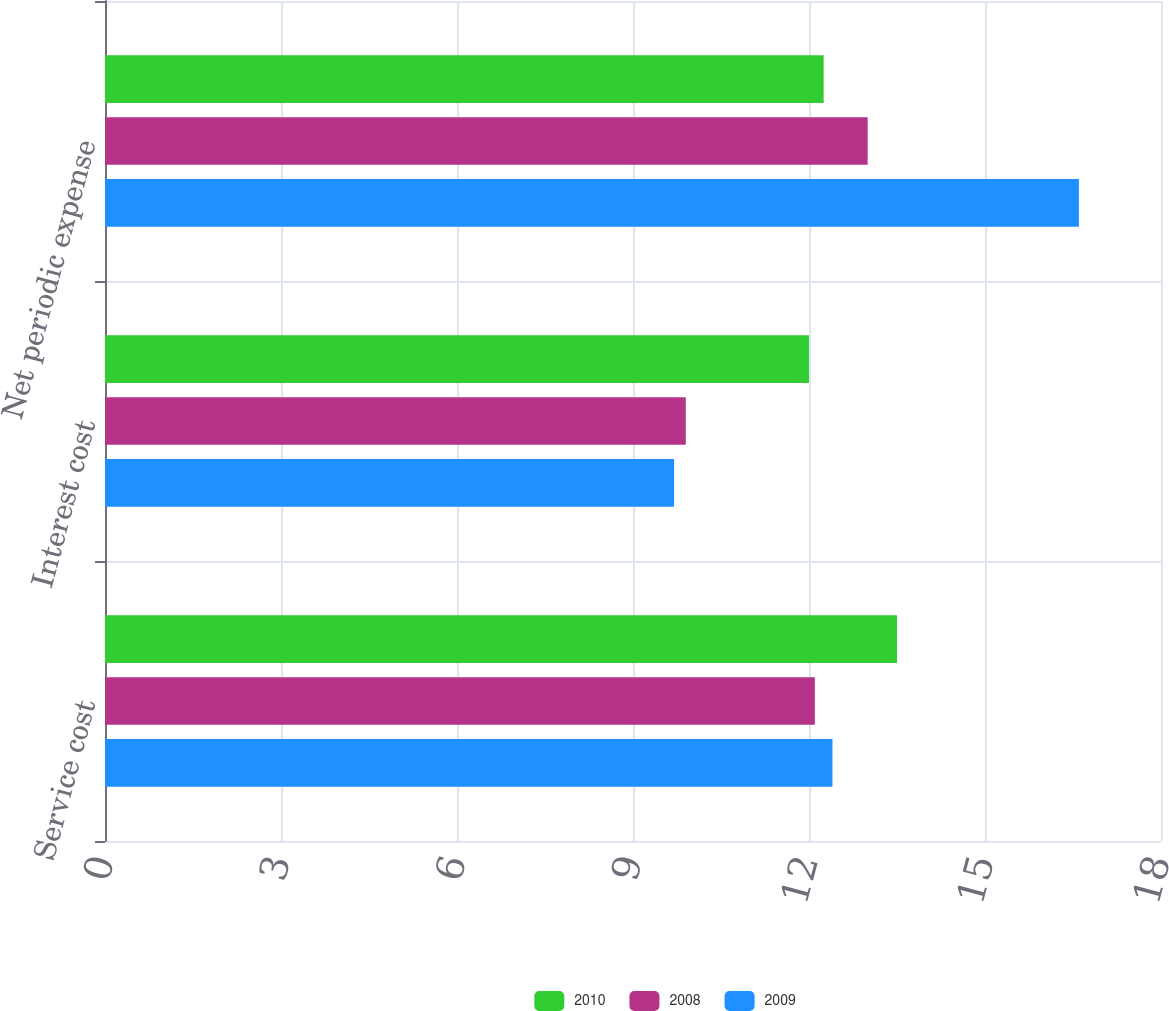<chart> <loc_0><loc_0><loc_500><loc_500><stacked_bar_chart><ecel><fcel>Service cost<fcel>Interest cost<fcel>Net periodic expense<nl><fcel>2010<fcel>13.5<fcel>12<fcel>12.25<nl><fcel>2008<fcel>12.1<fcel>9.9<fcel>13<nl><fcel>2009<fcel>12.4<fcel>9.7<fcel>16.6<nl></chart> 